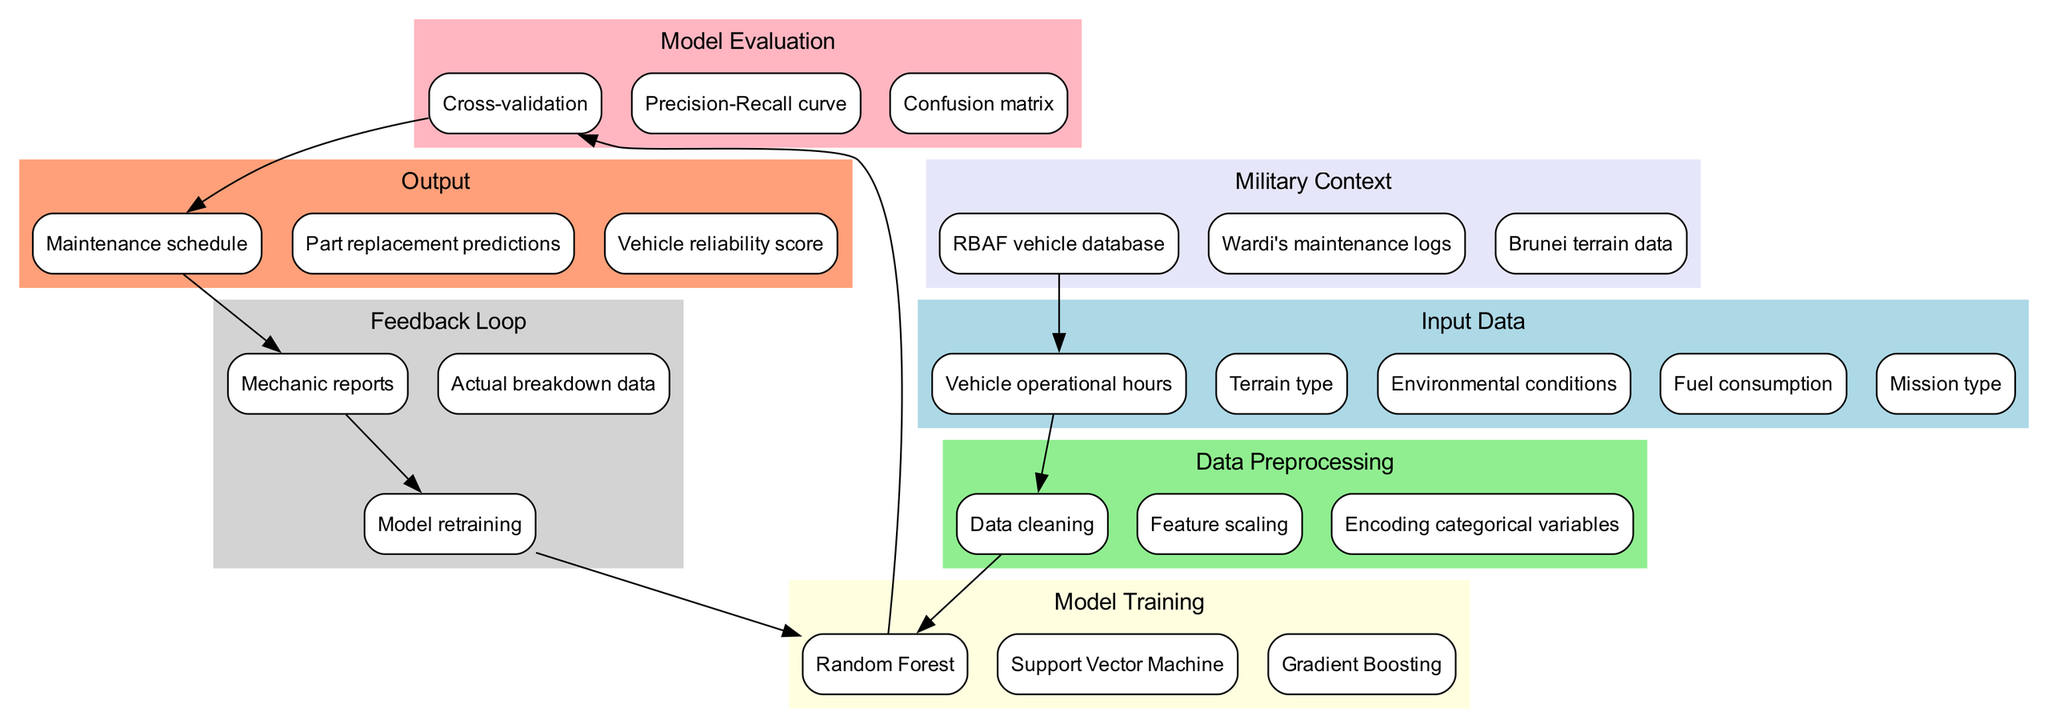What's the first step after inputting vehicle operational hours? After receiving vehicle operational hours, the first processing step outlined in the diagram is 'Data cleaning'. This sets the stage for preparing the data for the machine learning model.
Answer: Data cleaning Which model is used for training in this diagram? The diagram specifies three models for training: 'Random Forest', 'Support Vector Machine', and 'Gradient Boosting'. However, focusing on the first mentioned, the correct answer is 'Random Forest'.
Answer: Random Forest How many feedback loop elements are present? The feedback loop includes three distinct elements: 'Mechanic reports', 'Actual breakdown data', and 'Model retraining'. Therefore, the total number of elements in the feedback loop is three.
Answer: Three What is the output produced after the model evaluation? Following the model evaluation, the outputs generated include 'Maintenance schedule', 'Part replacement predictions', and 'Vehicle reliability score'. The first one mentioned is 'Maintenance schedule'.
Answer: Maintenance schedule What connects RBAF vehicle database to input data? The diagram shows that RBAF vehicle database directly influences 'Vehicle operational hours', indicating a flow from the military database to the model's input data regarding vehicle usage.
Answer: Vehicle operational hours What step follows 'Cross-validation' in the process? Based on the diagram's sequence, after performing 'Cross-validation', the next step is to generate the 'Maintenance schedule', which relies on the evaluation results of the model.
Answer: Maintenance schedule Which evaluation method appears in this diagram? The diagram outlines three evaluation methods: 'Cross-validation', 'Precision-Recall curve', and 'Confusion matrix'. However, focusing on just one, we can mention 'Cross-validation'.
Answer: Cross-validation What is included in the military context? The military context section of the diagram includes three items: 'RBAF vehicle database', 'Wardi's maintenance logs', and 'Brunei terrain data'. Additionally, an example from this context is 'Wardi's maintenance logs'.
Answer: Wardi's maintenance logs What part of the diagram indicates the use of environmental conditions? The 'Environmental conditions' are listed as part of the input data, showcasing that this information is utilized in the maintenance prediction model.
Answer: Input data 